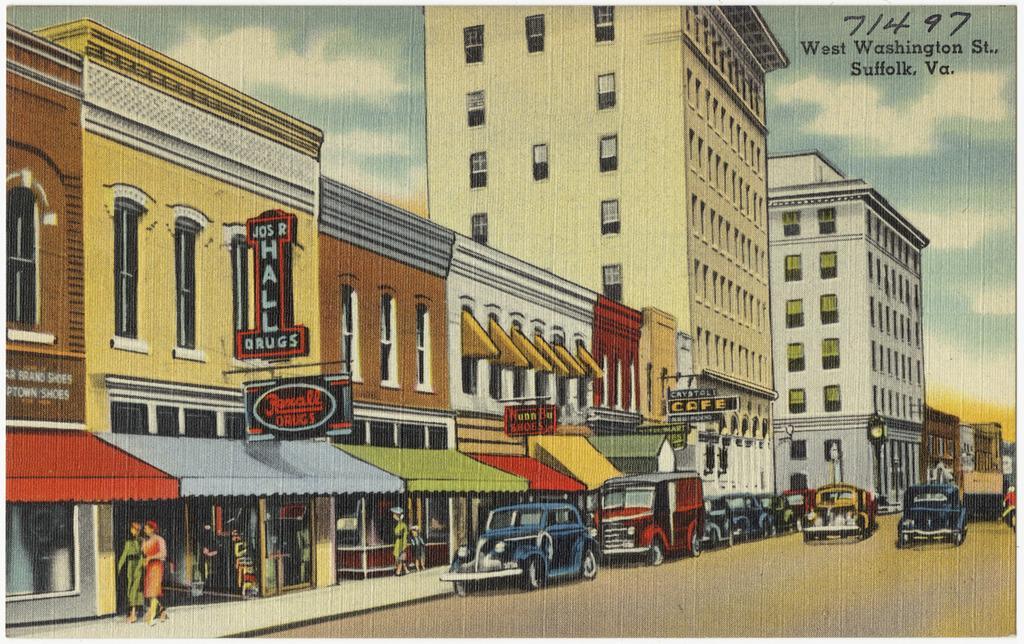Can you describe this image briefly? This is a cartoon image, in this image there is a road on that road vehicles are moving, beside the road there are buildings and shops near the shops people are walking, in the background there is sky. 